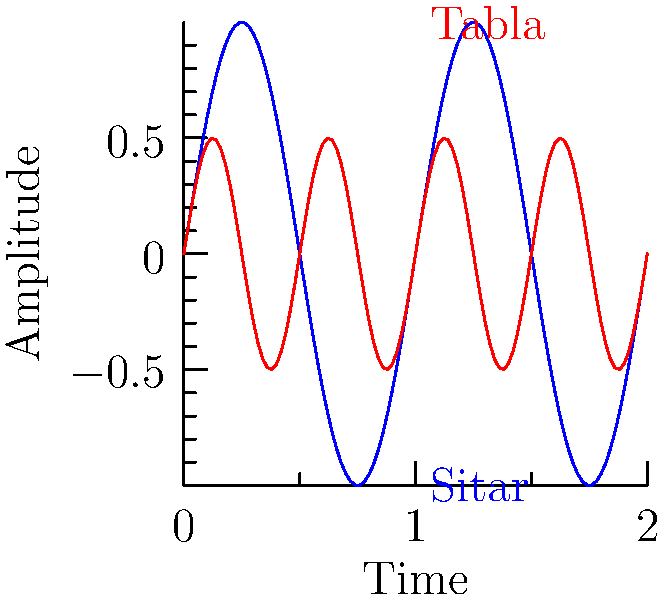In a popular Pakistani drama soundtrack, a sitar and a tabla are played simultaneously. The sound waves produced by these instruments are represented in the graph above. If the blue curve represents the sitar and the red curve represents the tabla, what can you conclude about the frequency and amplitude of the tabla compared to the sitar? To analyze the sound waves of the sitar and tabla, let's follow these steps:

1. Frequency comparison:
   - Frequency is related to the number of cycles in a given time period.
   - The blue curve (sitar) completes 1 cycle in the given time frame.
   - The red curve (tabla) completes 2 cycles in the same time frame.
   - Therefore, the tabla has twice the frequency of the sitar.

2. Amplitude comparison:
   - Amplitude is the maximum displacement from the equilibrium position.
   - The blue curve (sitar) has a maximum displacement of 1 unit.
   - The red curve (tabla) has a maximum displacement of 0.5 units.
   - Therefore, the tabla has half the amplitude of the sitar.

3. Mathematical representation:
   - Sitar wave: $y = \sin(2\pi x)$
   - Tabla wave: $y = 0.5\sin(4\pi x)$
   - The coefficient of $x$ in the sine function represents the frequency.
   - The coefficient before the sine function represents the amplitude.

4. Conclusion:
   - The tabla has double the frequency and half the amplitude of the sitar.
Answer: Double frequency, half amplitude 